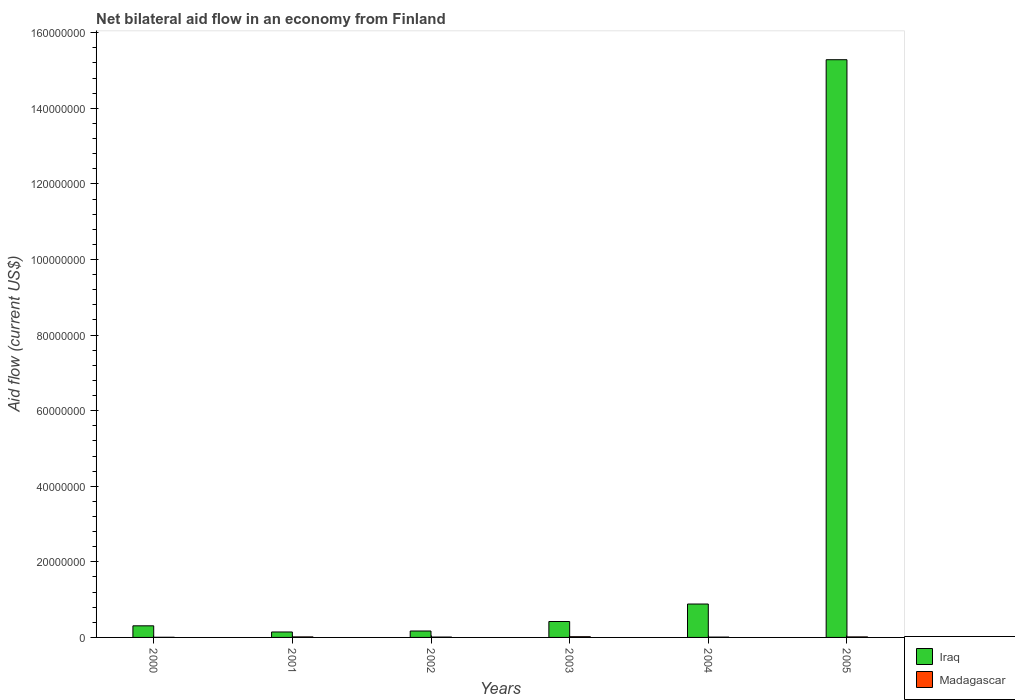How many groups of bars are there?
Offer a very short reply. 6. How many bars are there on the 2nd tick from the left?
Give a very brief answer. 2. What is the net bilateral aid flow in Iraq in 2002?
Offer a very short reply. 1.70e+06. Across all years, what is the minimum net bilateral aid flow in Iraq?
Ensure brevity in your answer.  1.44e+06. In which year was the net bilateral aid flow in Madagascar maximum?
Offer a very short reply. 2003. In which year was the net bilateral aid flow in Madagascar minimum?
Ensure brevity in your answer.  2000. What is the total net bilateral aid flow in Madagascar in the graph?
Your answer should be very brief. 7.00e+05. What is the difference between the net bilateral aid flow in Iraq in 2003 and that in 2004?
Keep it short and to the point. -4.63e+06. What is the difference between the net bilateral aid flow in Madagascar in 2000 and the net bilateral aid flow in Iraq in 2005?
Your answer should be compact. -1.53e+08. What is the average net bilateral aid flow in Madagascar per year?
Your answer should be very brief. 1.17e+05. In the year 2001, what is the difference between the net bilateral aid flow in Iraq and net bilateral aid flow in Madagascar?
Your answer should be very brief. 1.30e+06. In how many years, is the net bilateral aid flow in Madagascar greater than 12000000 US$?
Ensure brevity in your answer.  0. What is the ratio of the net bilateral aid flow in Iraq in 2002 to that in 2004?
Your answer should be compact. 0.19. What is the difference between the highest and the lowest net bilateral aid flow in Iraq?
Provide a succinct answer. 1.51e+08. Is the sum of the net bilateral aid flow in Madagascar in 2001 and 2004 greater than the maximum net bilateral aid flow in Iraq across all years?
Offer a very short reply. No. What does the 1st bar from the left in 2005 represents?
Provide a succinct answer. Iraq. What does the 2nd bar from the right in 2004 represents?
Ensure brevity in your answer.  Iraq. How many bars are there?
Keep it short and to the point. 12. Are all the bars in the graph horizontal?
Give a very brief answer. No. How many years are there in the graph?
Your response must be concise. 6. Are the values on the major ticks of Y-axis written in scientific E-notation?
Ensure brevity in your answer.  No. Does the graph contain any zero values?
Keep it short and to the point. No. Does the graph contain grids?
Provide a short and direct response. No. Where does the legend appear in the graph?
Your response must be concise. Bottom right. How many legend labels are there?
Your response must be concise. 2. What is the title of the graph?
Ensure brevity in your answer.  Net bilateral aid flow in an economy from Finland. Does "Thailand" appear as one of the legend labels in the graph?
Provide a succinct answer. No. What is the label or title of the Y-axis?
Keep it short and to the point. Aid flow (current US$). What is the Aid flow (current US$) in Iraq in 2000?
Give a very brief answer. 3.07e+06. What is the Aid flow (current US$) of Iraq in 2001?
Your answer should be compact. 1.44e+06. What is the Aid flow (current US$) of Madagascar in 2001?
Your answer should be very brief. 1.40e+05. What is the Aid flow (current US$) of Iraq in 2002?
Keep it short and to the point. 1.70e+06. What is the Aid flow (current US$) in Madagascar in 2002?
Provide a succinct answer. 1.00e+05. What is the Aid flow (current US$) in Iraq in 2003?
Your response must be concise. 4.21e+06. What is the Aid flow (current US$) in Madagascar in 2003?
Give a very brief answer. 1.90e+05. What is the Aid flow (current US$) in Iraq in 2004?
Your response must be concise. 8.84e+06. What is the Aid flow (current US$) in Iraq in 2005?
Your answer should be compact. 1.53e+08. What is the Aid flow (current US$) of Madagascar in 2005?
Provide a short and direct response. 1.40e+05. Across all years, what is the maximum Aid flow (current US$) in Iraq?
Your response must be concise. 1.53e+08. Across all years, what is the minimum Aid flow (current US$) in Iraq?
Ensure brevity in your answer.  1.44e+06. Across all years, what is the minimum Aid flow (current US$) of Madagascar?
Ensure brevity in your answer.  4.00e+04. What is the total Aid flow (current US$) of Iraq in the graph?
Provide a succinct answer. 1.72e+08. What is the difference between the Aid flow (current US$) of Iraq in 2000 and that in 2001?
Provide a succinct answer. 1.63e+06. What is the difference between the Aid flow (current US$) in Madagascar in 2000 and that in 2001?
Offer a terse response. -1.00e+05. What is the difference between the Aid flow (current US$) in Iraq in 2000 and that in 2002?
Give a very brief answer. 1.37e+06. What is the difference between the Aid flow (current US$) of Iraq in 2000 and that in 2003?
Provide a short and direct response. -1.14e+06. What is the difference between the Aid flow (current US$) of Madagascar in 2000 and that in 2003?
Give a very brief answer. -1.50e+05. What is the difference between the Aid flow (current US$) of Iraq in 2000 and that in 2004?
Ensure brevity in your answer.  -5.77e+06. What is the difference between the Aid flow (current US$) in Madagascar in 2000 and that in 2004?
Give a very brief answer. -5.00e+04. What is the difference between the Aid flow (current US$) of Iraq in 2000 and that in 2005?
Keep it short and to the point. -1.50e+08. What is the difference between the Aid flow (current US$) of Madagascar in 2000 and that in 2005?
Provide a succinct answer. -1.00e+05. What is the difference between the Aid flow (current US$) in Iraq in 2001 and that in 2002?
Provide a short and direct response. -2.60e+05. What is the difference between the Aid flow (current US$) in Iraq in 2001 and that in 2003?
Offer a very short reply. -2.77e+06. What is the difference between the Aid flow (current US$) of Madagascar in 2001 and that in 2003?
Ensure brevity in your answer.  -5.00e+04. What is the difference between the Aid flow (current US$) in Iraq in 2001 and that in 2004?
Ensure brevity in your answer.  -7.40e+06. What is the difference between the Aid flow (current US$) in Iraq in 2001 and that in 2005?
Your answer should be compact. -1.51e+08. What is the difference between the Aid flow (current US$) in Iraq in 2002 and that in 2003?
Provide a short and direct response. -2.51e+06. What is the difference between the Aid flow (current US$) of Madagascar in 2002 and that in 2003?
Provide a short and direct response. -9.00e+04. What is the difference between the Aid flow (current US$) of Iraq in 2002 and that in 2004?
Provide a succinct answer. -7.14e+06. What is the difference between the Aid flow (current US$) in Iraq in 2002 and that in 2005?
Make the answer very short. -1.51e+08. What is the difference between the Aid flow (current US$) of Iraq in 2003 and that in 2004?
Give a very brief answer. -4.63e+06. What is the difference between the Aid flow (current US$) in Madagascar in 2003 and that in 2004?
Ensure brevity in your answer.  1.00e+05. What is the difference between the Aid flow (current US$) in Iraq in 2003 and that in 2005?
Your answer should be very brief. -1.49e+08. What is the difference between the Aid flow (current US$) of Madagascar in 2003 and that in 2005?
Provide a short and direct response. 5.00e+04. What is the difference between the Aid flow (current US$) in Iraq in 2004 and that in 2005?
Your response must be concise. -1.44e+08. What is the difference between the Aid flow (current US$) in Iraq in 2000 and the Aid flow (current US$) in Madagascar in 2001?
Your answer should be very brief. 2.93e+06. What is the difference between the Aid flow (current US$) of Iraq in 2000 and the Aid flow (current US$) of Madagascar in 2002?
Your answer should be very brief. 2.97e+06. What is the difference between the Aid flow (current US$) in Iraq in 2000 and the Aid flow (current US$) in Madagascar in 2003?
Offer a very short reply. 2.88e+06. What is the difference between the Aid flow (current US$) in Iraq in 2000 and the Aid flow (current US$) in Madagascar in 2004?
Offer a very short reply. 2.98e+06. What is the difference between the Aid flow (current US$) of Iraq in 2000 and the Aid flow (current US$) of Madagascar in 2005?
Ensure brevity in your answer.  2.93e+06. What is the difference between the Aid flow (current US$) in Iraq in 2001 and the Aid flow (current US$) in Madagascar in 2002?
Ensure brevity in your answer.  1.34e+06. What is the difference between the Aid flow (current US$) of Iraq in 2001 and the Aid flow (current US$) of Madagascar in 2003?
Provide a succinct answer. 1.25e+06. What is the difference between the Aid flow (current US$) in Iraq in 2001 and the Aid flow (current US$) in Madagascar in 2004?
Offer a terse response. 1.35e+06. What is the difference between the Aid flow (current US$) of Iraq in 2001 and the Aid flow (current US$) of Madagascar in 2005?
Provide a succinct answer. 1.30e+06. What is the difference between the Aid flow (current US$) of Iraq in 2002 and the Aid flow (current US$) of Madagascar in 2003?
Make the answer very short. 1.51e+06. What is the difference between the Aid flow (current US$) in Iraq in 2002 and the Aid flow (current US$) in Madagascar in 2004?
Your answer should be compact. 1.61e+06. What is the difference between the Aid flow (current US$) of Iraq in 2002 and the Aid flow (current US$) of Madagascar in 2005?
Keep it short and to the point. 1.56e+06. What is the difference between the Aid flow (current US$) of Iraq in 2003 and the Aid flow (current US$) of Madagascar in 2004?
Your answer should be compact. 4.12e+06. What is the difference between the Aid flow (current US$) in Iraq in 2003 and the Aid flow (current US$) in Madagascar in 2005?
Keep it short and to the point. 4.07e+06. What is the difference between the Aid flow (current US$) in Iraq in 2004 and the Aid flow (current US$) in Madagascar in 2005?
Your response must be concise. 8.70e+06. What is the average Aid flow (current US$) in Iraq per year?
Provide a succinct answer. 2.87e+07. What is the average Aid flow (current US$) in Madagascar per year?
Your response must be concise. 1.17e+05. In the year 2000, what is the difference between the Aid flow (current US$) in Iraq and Aid flow (current US$) in Madagascar?
Provide a succinct answer. 3.03e+06. In the year 2001, what is the difference between the Aid flow (current US$) of Iraq and Aid flow (current US$) of Madagascar?
Offer a very short reply. 1.30e+06. In the year 2002, what is the difference between the Aid flow (current US$) in Iraq and Aid flow (current US$) in Madagascar?
Give a very brief answer. 1.60e+06. In the year 2003, what is the difference between the Aid flow (current US$) in Iraq and Aid flow (current US$) in Madagascar?
Your answer should be compact. 4.02e+06. In the year 2004, what is the difference between the Aid flow (current US$) in Iraq and Aid flow (current US$) in Madagascar?
Make the answer very short. 8.75e+06. In the year 2005, what is the difference between the Aid flow (current US$) of Iraq and Aid flow (current US$) of Madagascar?
Offer a very short reply. 1.53e+08. What is the ratio of the Aid flow (current US$) in Iraq in 2000 to that in 2001?
Provide a short and direct response. 2.13. What is the ratio of the Aid flow (current US$) of Madagascar in 2000 to that in 2001?
Offer a terse response. 0.29. What is the ratio of the Aid flow (current US$) in Iraq in 2000 to that in 2002?
Make the answer very short. 1.81. What is the ratio of the Aid flow (current US$) in Iraq in 2000 to that in 2003?
Your response must be concise. 0.73. What is the ratio of the Aid flow (current US$) in Madagascar in 2000 to that in 2003?
Provide a short and direct response. 0.21. What is the ratio of the Aid flow (current US$) in Iraq in 2000 to that in 2004?
Provide a short and direct response. 0.35. What is the ratio of the Aid flow (current US$) of Madagascar in 2000 to that in 2004?
Offer a very short reply. 0.44. What is the ratio of the Aid flow (current US$) in Iraq in 2000 to that in 2005?
Your response must be concise. 0.02. What is the ratio of the Aid flow (current US$) in Madagascar in 2000 to that in 2005?
Make the answer very short. 0.29. What is the ratio of the Aid flow (current US$) of Iraq in 2001 to that in 2002?
Offer a very short reply. 0.85. What is the ratio of the Aid flow (current US$) of Iraq in 2001 to that in 2003?
Make the answer very short. 0.34. What is the ratio of the Aid flow (current US$) of Madagascar in 2001 to that in 2003?
Ensure brevity in your answer.  0.74. What is the ratio of the Aid flow (current US$) of Iraq in 2001 to that in 2004?
Offer a very short reply. 0.16. What is the ratio of the Aid flow (current US$) of Madagascar in 2001 to that in 2004?
Your answer should be compact. 1.56. What is the ratio of the Aid flow (current US$) in Iraq in 2001 to that in 2005?
Your response must be concise. 0.01. What is the ratio of the Aid flow (current US$) in Madagascar in 2001 to that in 2005?
Your response must be concise. 1. What is the ratio of the Aid flow (current US$) of Iraq in 2002 to that in 2003?
Your answer should be compact. 0.4. What is the ratio of the Aid flow (current US$) in Madagascar in 2002 to that in 2003?
Provide a succinct answer. 0.53. What is the ratio of the Aid flow (current US$) in Iraq in 2002 to that in 2004?
Keep it short and to the point. 0.19. What is the ratio of the Aid flow (current US$) in Madagascar in 2002 to that in 2004?
Keep it short and to the point. 1.11. What is the ratio of the Aid flow (current US$) of Iraq in 2002 to that in 2005?
Ensure brevity in your answer.  0.01. What is the ratio of the Aid flow (current US$) in Iraq in 2003 to that in 2004?
Offer a very short reply. 0.48. What is the ratio of the Aid flow (current US$) of Madagascar in 2003 to that in 2004?
Ensure brevity in your answer.  2.11. What is the ratio of the Aid flow (current US$) in Iraq in 2003 to that in 2005?
Ensure brevity in your answer.  0.03. What is the ratio of the Aid flow (current US$) in Madagascar in 2003 to that in 2005?
Ensure brevity in your answer.  1.36. What is the ratio of the Aid flow (current US$) of Iraq in 2004 to that in 2005?
Provide a short and direct response. 0.06. What is the ratio of the Aid flow (current US$) in Madagascar in 2004 to that in 2005?
Give a very brief answer. 0.64. What is the difference between the highest and the second highest Aid flow (current US$) of Iraq?
Your response must be concise. 1.44e+08. What is the difference between the highest and the lowest Aid flow (current US$) of Iraq?
Provide a short and direct response. 1.51e+08. 